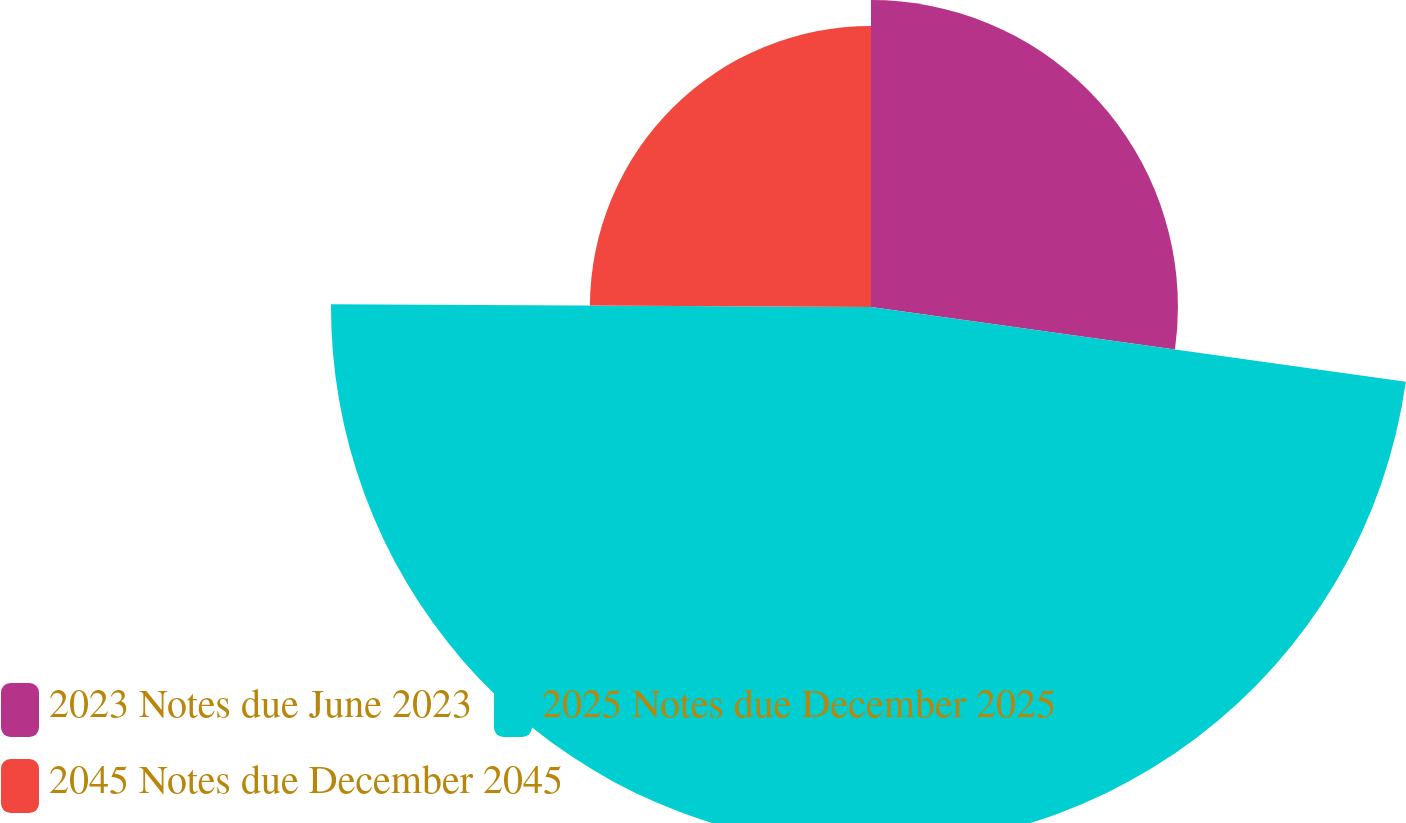<chart> <loc_0><loc_0><loc_500><loc_500><pie_chart><fcel>2023 Notes due June 2023<fcel>2025 Notes due December 2025<fcel>2045 Notes due December 2045<nl><fcel>27.21%<fcel>47.87%<fcel>24.92%<nl></chart> 